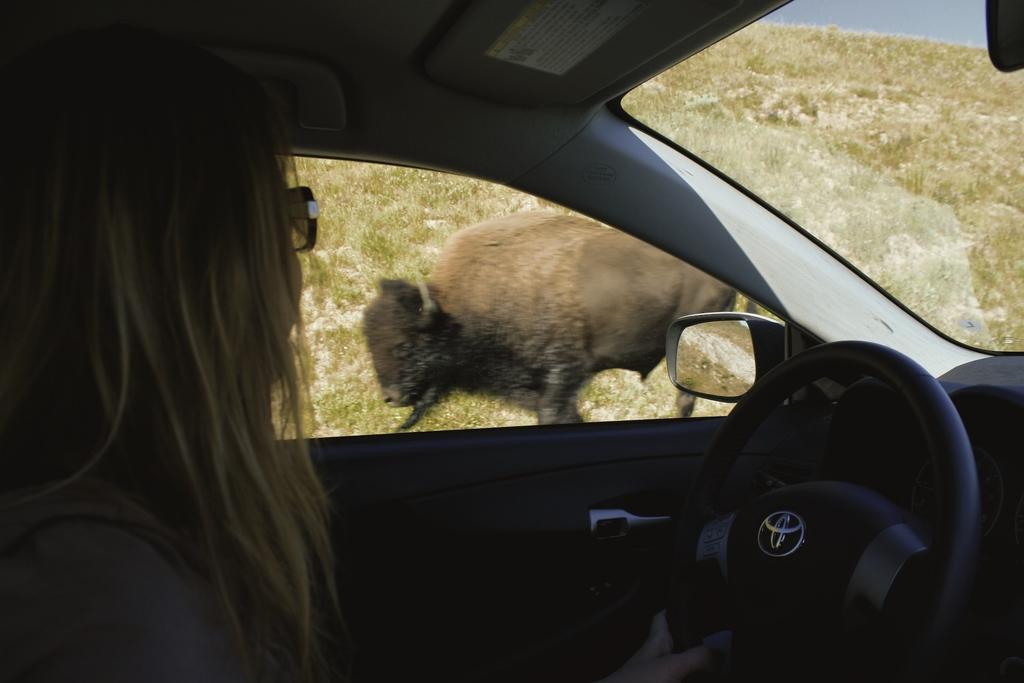Describe this image in one or two sentences. In this image I see the inside view of vehicle and I see that there is a woman who is sitting and holding the steering in one hand. In the background I see an animal over here and I see the grass. 